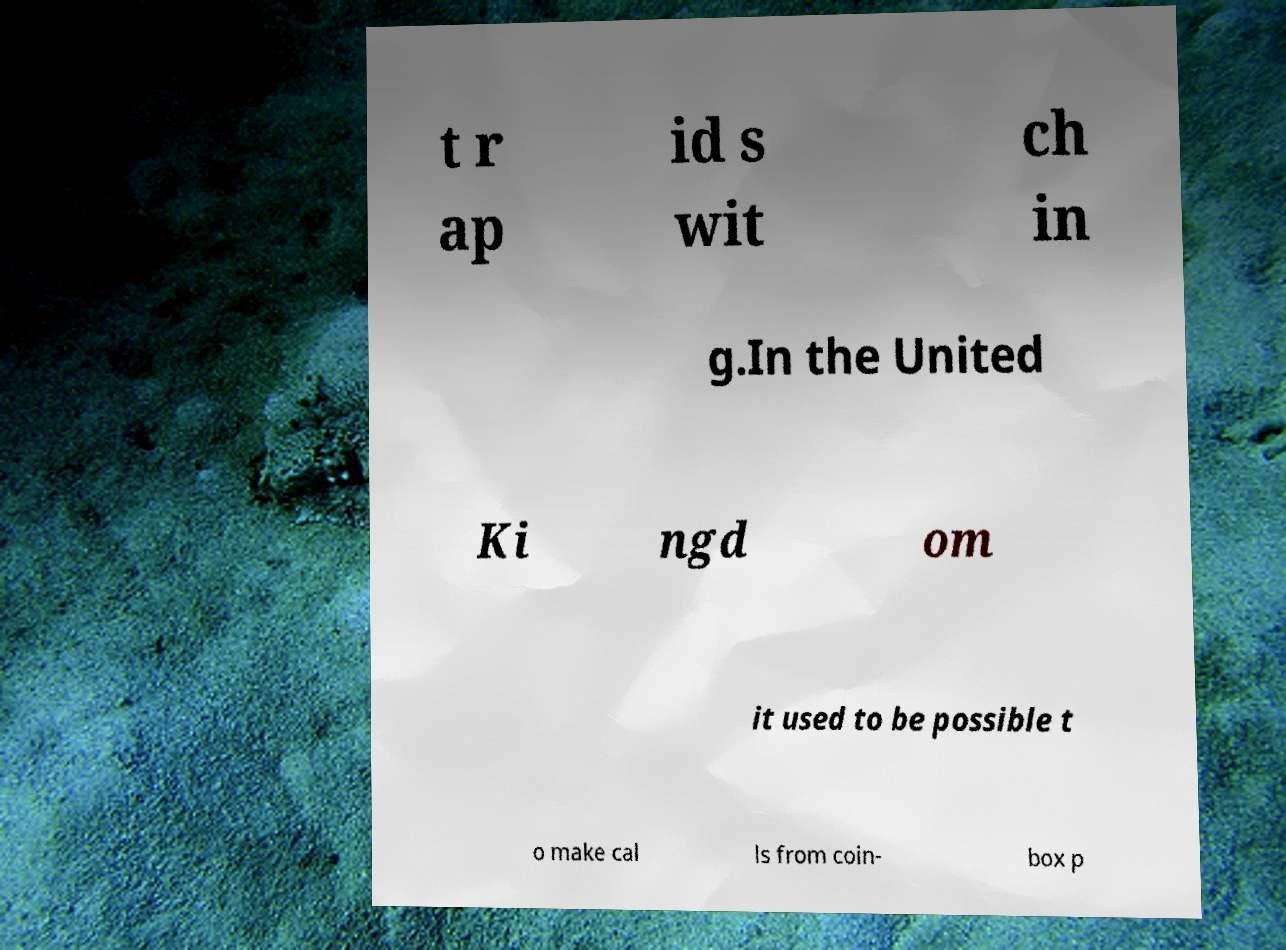Can you accurately transcribe the text from the provided image for me? t r ap id s wit ch in g.In the United Ki ngd om it used to be possible t o make cal ls from coin- box p 